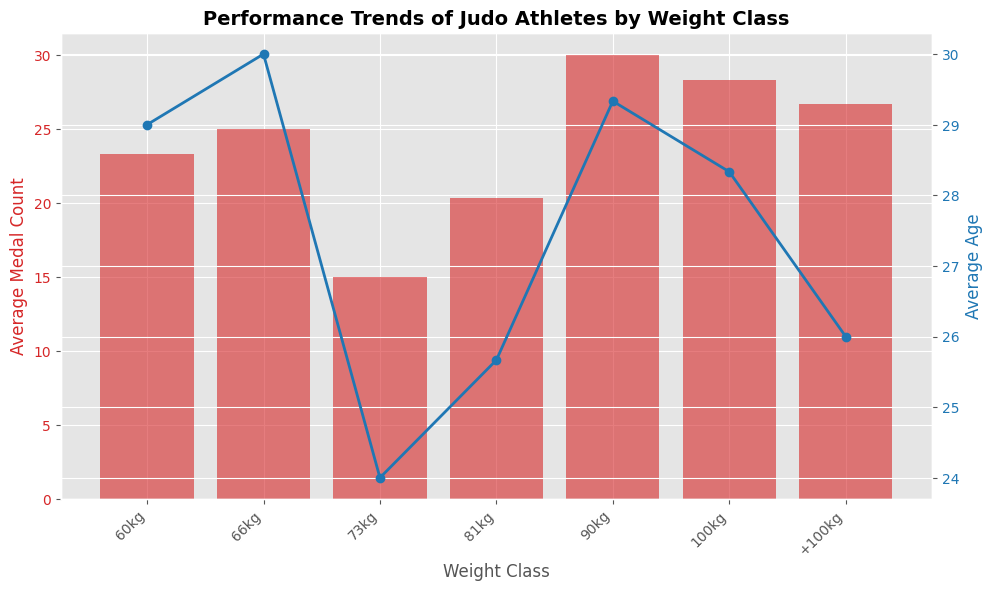Which weight class has the highest average medal count? From the bar chart, visually identify the weight class with the tallest bar. Both the 73kg and 90kg classes have high average medal counts. By comparing their heights, it's evident that the 73kg class has the tallest bar.
Answer: 73kg Which weight class has the lowest average age? From the line chart, identify the weight class with the lowest point on the blue line. The 60kg class has the lowest point on the line, indicating the lowest average age.
Answer: 60kg What's the difference in average age between the 66kg and +100kg weight classes? Locate the 66kg and +100kg points on the blue line representing the average age. The average age for the 66kg class is 26, and for the +100kg class, it is 29. Calculate the difference: 29 - 26 = 3.
Answer: 3 Compare the average medal counts between the 81kg and 100kg weight classes. Which one is higher and by how much? From the bar chart, identify the heights of the bars for the 81kg and 100kg weight classes. The 100kg class has a higher average medal count than the 81kg class. Calculate the difference: 25 (100kg) - 28 (81kg) = -3. The 81kg class has a higher medal count by 3.
Answer: 81kg by 3 Is there a noticeable trend in average age as weight class increases? Examine the points on the line representing the average age from left to right. Generally, the age tends to increase with higher weight classes, especially after the 66kg weight class, suggesting a positive trend.
Answer: Yes What is the total average medal count for the weight classes under 90kg? Sum the average medal counts of the weight classes under 90kg: 60kg (15), 66kg (20), and 73kg (30). Calculate the sum: 15 + 20 + 30 = 65.
Answer: 65 Which weight class shows an approximately equal average medal count and average age? Compare the heights of the bars (medal count) with the points on the line chart (age) for each weight class. The 90kg class shows an average medal count close to its average age, both around 25.
Answer: 90kg What is the average age difference between the lightest and the heaviest weight classes? Identify the average ages for the 60kg (lightest) and +100kg (heaviest) weight classes from the line chart. Average age for 60kg is 24, and for +100kg, it is 29. Calculate the difference: 29 - 24 = 5.
Answer: 5 Which weight class has a higher average medal count: 60kg or 66kg? By how much? Compare the heights of the bars for the 60kg and 66kg weight classes. The 66kg class has a higher average medal count. Calculate the difference: 20 (66kg) - 15 (60kg) = 5.
Answer: 66kg by 5 How does the average age of the 73kg class compare to the average age of the 90kg class? Locate the points on the line chart for the 73kg and 90kg classes. The average age for the 73kg class is 29, while for the 90kg class, it is 25. The 73kg class is older.
Answer: 73kg is older by 4 years 